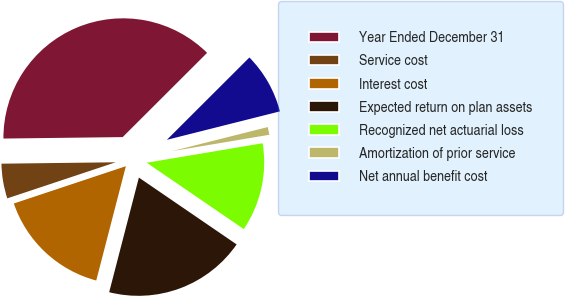<chart> <loc_0><loc_0><loc_500><loc_500><pie_chart><fcel>Year Ended December 31<fcel>Service cost<fcel>Interest cost<fcel>Expected return on plan assets<fcel>Recognized net actuarial loss<fcel>Amortization of prior service<fcel>Net annual benefit cost<nl><fcel>37.71%<fcel>4.92%<fcel>15.85%<fcel>19.49%<fcel>12.2%<fcel>1.27%<fcel>8.56%<nl></chart> 